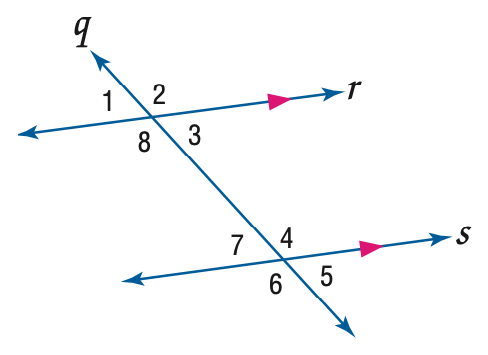Question: Use the figure to find the indicated variable. Find y if m \angle 3 = 4 y + 30 and m \angle 7 = 7 y + 6.
Choices:
A. 8
B. 9
C. 10
D. 12
Answer with the letter. Answer: A 